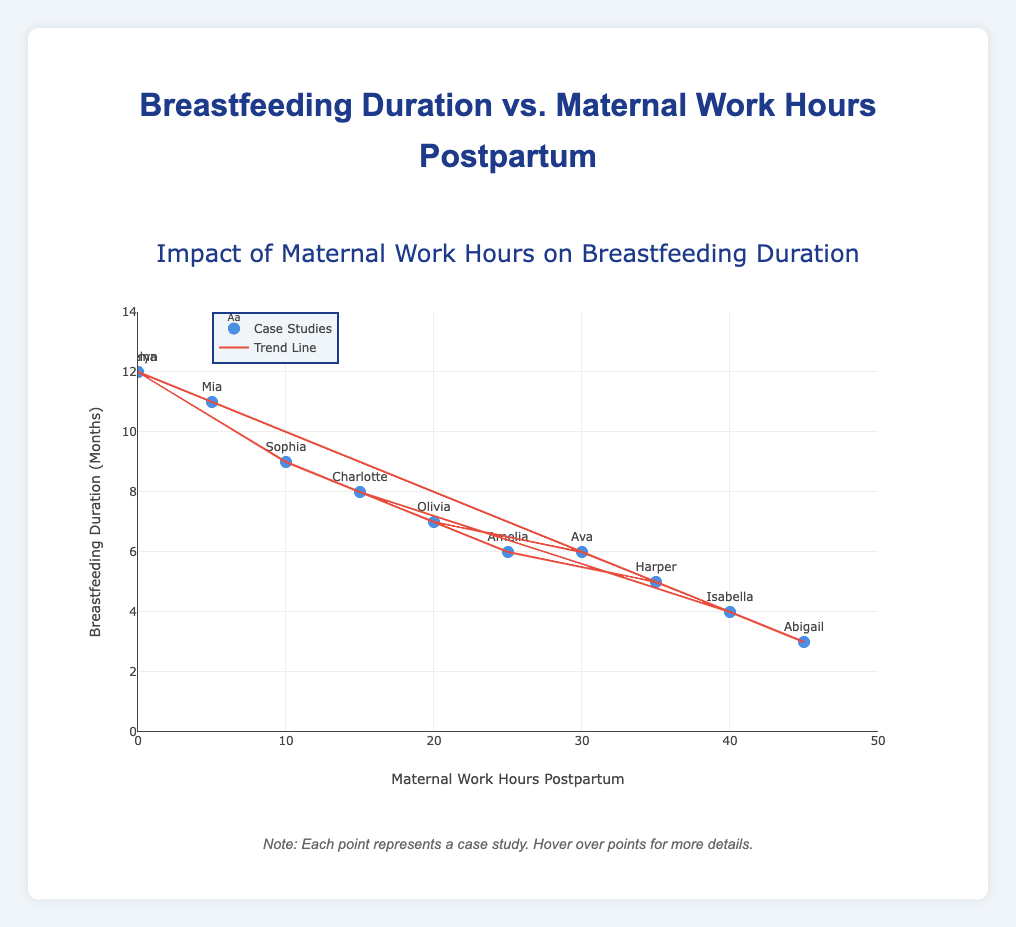What is the title of the plot? The title is usually prominently displayed at the top of the plot and should be easy to spot. It is meant to give an overview of what the plot represents.
Answer: Breastfeeding Duration vs. Maternal Work Hours Postpartum How many case studies are represented in the plot? By counting the individual data points or markers on the plot, you can determine the number of case studies represented. There are 11 data points in the plot.
Answer: 11 Which case study had the highest number of postpartum work hours and what was their breastfeeding duration? To answer this, look for the data point at the farthest right of the plot along the x-axis and read the respective y-axis value. The case at 45 work hours had 3 months of breastfeeding.
Answer: Abigail had 45 work hours and 3 months breastfeeding Is there a trend between maternal work hours postpartum and breastfeeding duration? Looking at the alignment of the markers and the trend line can show whether the two variables move in a correlated manner. There is a negative trend line indicating that as maternal work hours increase, breastfeeding duration tends to decrease.
Answer: Yes, a negative trend exists What is the breastfeeding duration for mothers who did not work postpartum? Locate the points along the y-axis where the x-axis value is 0 to determine the corresponding breastfeeding durations. There are two such points, each with a duration of 12 months.
Answer: 12 months How does the trend line visually relate to the scatter plot of data points? The trend line is plotted based on the overall trend of the data points. It weaves through the middle to represent the average relationship between maternal work hours postpartum and breastfeeding duration. The trend line is generally sloping downwards, indicating a decrease in breastfeeding duration with increased work hours.
Answer: The trend line shows a negative relationship Which case studies had the same breastfeeding duration but different work hours, and what were those values? Find multiple data points that share the same y-axis value but differ in x-axis values. Both Ava and Amelia had 6 months of breastfeeding but worked 30 and 25 hours postpartum, respectively.
Answer: Ava (30 hrs, 6 months) and Amelia (25 hrs, 6 months) What is the maximum breastfeeding duration recorded, and which work hours postpartum correspond to it? Identify the highest point along the y-axis and check the corresponding x-axis value. The maximum breastfeeding duration is 12 months, occurring at 0 work hours postpartum.
Answer: 12 months at 0 work hours Compare the breastfeeding durations of the mothers working 20 and 40 hours postpartum. Which case study had a higher breastfeeding duration and by how much? Locate the data points for 20 and 40 hours on the x-axis, and compare the respective y-values. Olivia (20 hrs) had 7 months and Isabella (40 hrs) had 4 months, so Olivia had 3 months more.
Answer: Olivia had 3 months more than Isabella What can be inferred about the relationship between breastfeeding duration and maternal work hours based on the trend line's slope? By observing the trend line's downward slope, it can be inferred that generally, as maternal work hours postpartum increase, breastfeeding duration decreases. The relationship is inversely proportional.
Answer: Maternal work hours inversely affect breastfeeding duration 